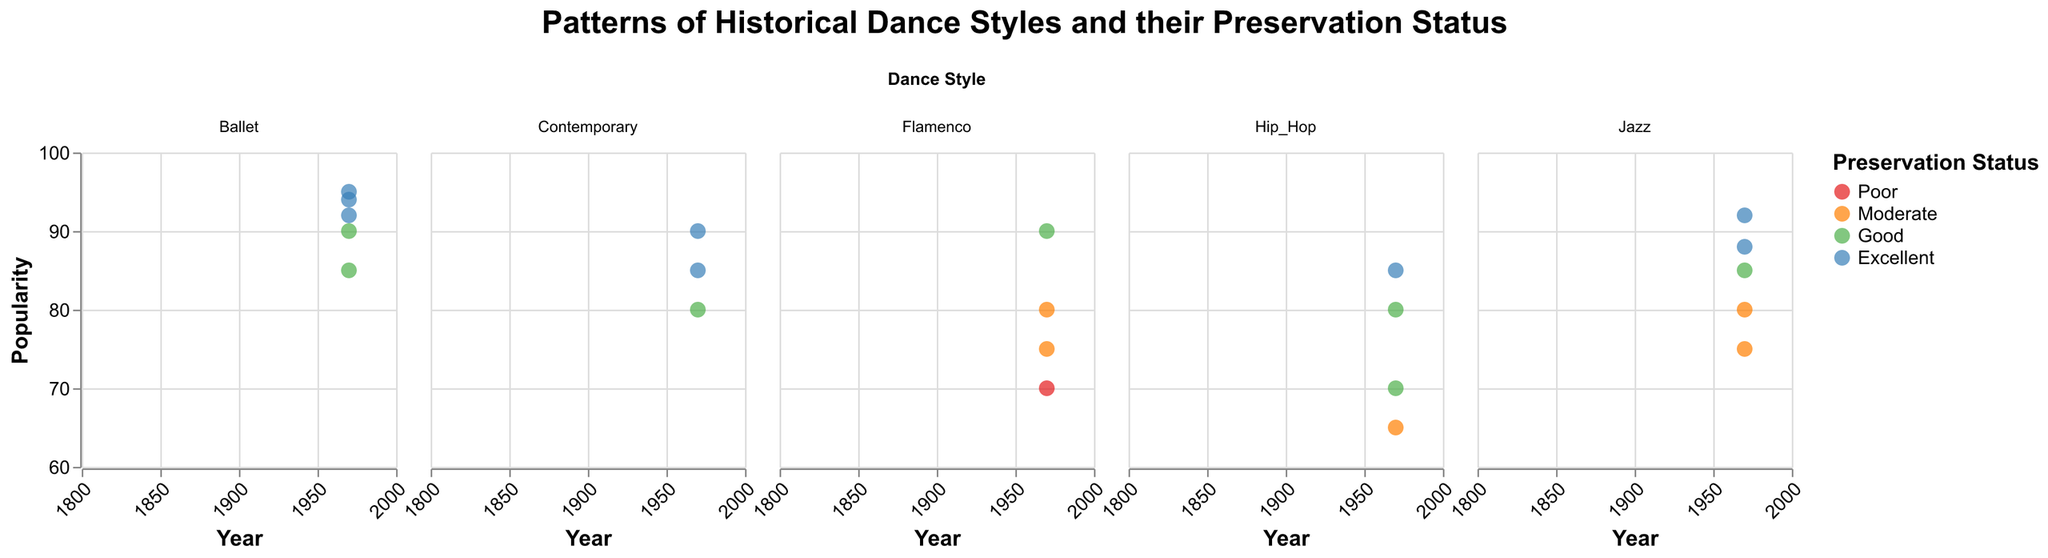What is the title of the figure? The title is displayed at the top center of the figure.
Answer: Patterns of Historical Dance Styles and their Preservation Status What year range is covered in the timeline of the figure? The x-axis represents the "Year" spanning from the earliest to the latest year. The range is clearly visible along this axis.
Answer: 1800 to 2000 Which dance styles have an "Excellent" preservation status in the year 2000? Each subplot corresponds to a different dance style. Look at each subplot for data points from the year 2000 with a color corresponding to "Excellent" preservation status.
Answer: Ballet, Jazz, Hip_Hop, Contemporary How does the popularity of Ballet change over the years covered in the figure? Observe the vertical placement of the data points in the "Ballet" subplot along the "Popularity" axis for the entire time range. The heights of the points and their increasing trend indicate increases or decreases in popularity.
Answer: Generally increasing How many dance styles have their earliest data point starting after 1900? Check each subplot (dance style) to identify the year of the first data point. Count dance styles where the first data point appears after 1900.
Answer: Two (Hip_Hop, Contemporary) What is the highest popularity recorded for Flamenco and in which year? Look at the "Flamenco" subplot and find the data point with the highest y-value on the "Popularity" axis. Note the corresponding year.
Answer: 90 in 2000 Which dance style experienced an increase in popularity from 1990 to 2000 but remained under "Good" preservation status in 1990? Look for dance styles that have data points for both 1990 and 2000. Check their preservation status in 1990, and compare popularity from 1990 to 2000.
Answer: Hip_Hop Which dance style has the largest variation in preservation status across all the years in the dataset? Look at each subplot for changes in color of data points, indicating different preservation statuses, and count the number of unique statuses for each dance style.
Answer: Flamenco In which decades does Jazz show a transition from "Moderate" to "Excellent" preservation status? Examine the "Jazz" subplot to identify the years where the preservation status color changes from "Moderate" to "Excellent." Note the decades these years belong to.
Answer: 1960s to 1980s What is the average popularity of Contemporary dance style in the dataset? Sum all the "Popularity" values for the Contemporary subplot and divide by the number of data points (3).
Answer: (80+85+90)/3 = 85 